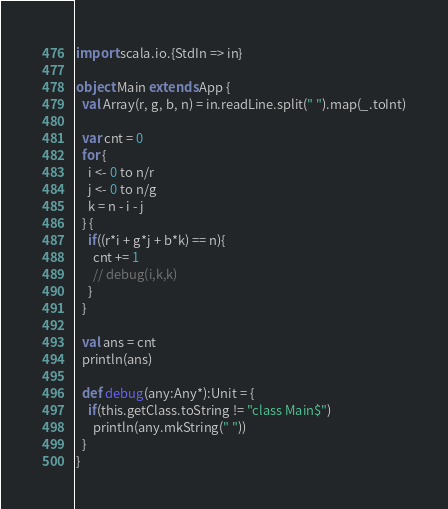Convert code to text. <code><loc_0><loc_0><loc_500><loc_500><_Scala_>import scala.io.{StdIn => in}

object Main extends App {
  val Array(r, g, b, n) = in.readLine.split(" ").map(_.toInt)

  var cnt = 0
  for {
    i <- 0 to n/r
    j <- 0 to n/g
    k = n - i - j
  } {
    if((r*i + g*j + b*k) == n){
      cnt += 1
      // debug(i,k,k)
    }
  }

  val ans = cnt
  println(ans)

  def debug(any:Any*):Unit = {
    if(this.getClass.toString != "class Main$")
      println(any.mkString(" "))
  }
}</code> 